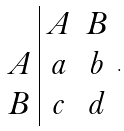Convert formula to latex. <formula><loc_0><loc_0><loc_500><loc_500>\begin{array} { c | c c } & A & B \\ A & a & b \\ B & c & d \end{array} .</formula> 